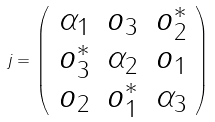Convert formula to latex. <formula><loc_0><loc_0><loc_500><loc_500>j = \left ( \begin{array} { c c c } \alpha _ { 1 } & o _ { 3 } & o _ { 2 } ^ { * } \\ o _ { 3 } ^ { * } & \alpha _ { 2 } & o _ { 1 } \\ o _ { 2 } & o _ { 1 } ^ { * } & \alpha _ { 3 } \end{array} \right )</formula> 